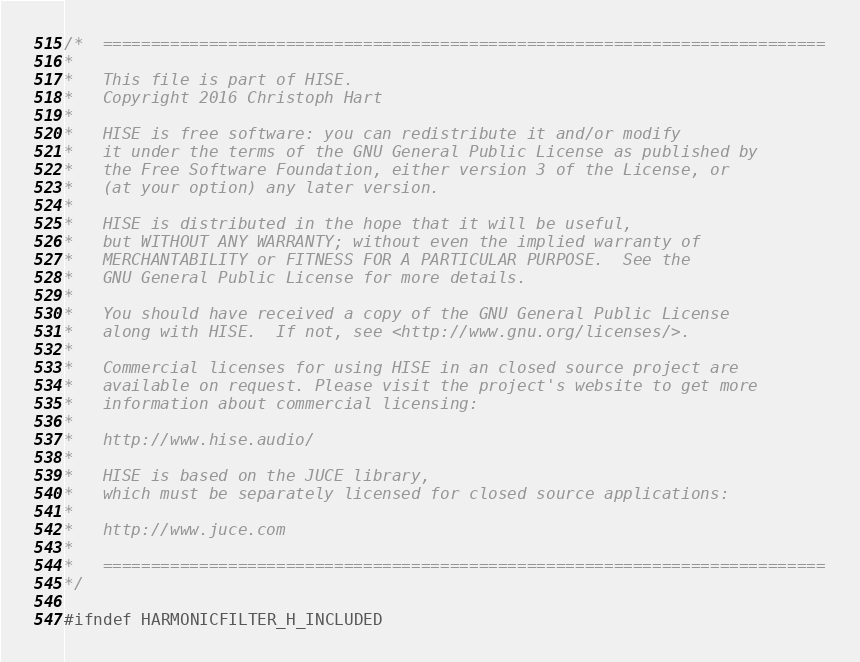<code> <loc_0><loc_0><loc_500><loc_500><_C_>/*  ===========================================================================
*
*   This file is part of HISE.
*   Copyright 2016 Christoph Hart
*
*   HISE is free software: you can redistribute it and/or modify
*   it under the terms of the GNU General Public License as published by
*   the Free Software Foundation, either version 3 of the License, or
*   (at your option) any later version.
*
*   HISE is distributed in the hope that it will be useful,
*   but WITHOUT ANY WARRANTY; without even the implied warranty of
*   MERCHANTABILITY or FITNESS FOR A PARTICULAR PURPOSE.  See the
*   GNU General Public License for more details.
*
*   You should have received a copy of the GNU General Public License
*   along with HISE.  If not, see <http://www.gnu.org/licenses/>.
*
*   Commercial licenses for using HISE in an closed source project are
*   available on request. Please visit the project's website to get more
*   information about commercial licensing:
*
*   http://www.hise.audio/
*
*   HISE is based on the JUCE library,
*   which must be separately licensed for closed source applications:
*
*   http://www.juce.com
*
*   ===========================================================================
*/

#ifndef HARMONICFILTER_H_INCLUDED</code> 